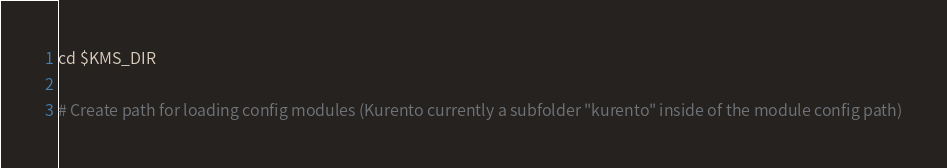Convert code to text. <code><loc_0><loc_0><loc_500><loc_500><_Bash_>cd $KMS_DIR

# Create path for loading config modules (Kurento currently a subfolder "kurento" inside of the module config path)</code> 